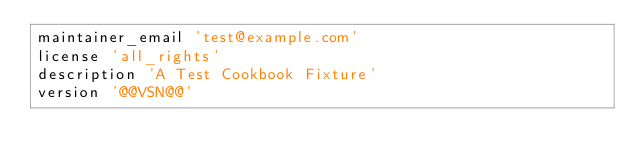Convert code to text. <code><loc_0><loc_0><loc_500><loc_500><_Ruby_>maintainer_email 'test@example.com'
license 'all_rights'
description 'A Test Cookbook Fixture'
version '@@VSN@@'
</code> 